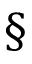Convert formula to latex. <formula><loc_0><loc_0><loc_500><loc_500>\S</formula> 